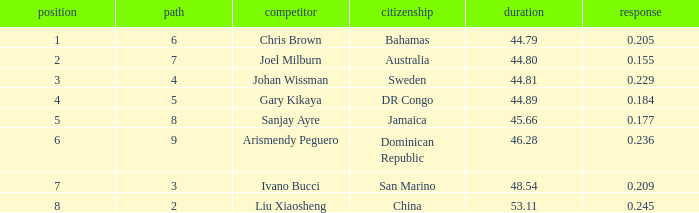What Lane has a 0.209 React entered with a Rank entry that is larger than 6? 2.0. 